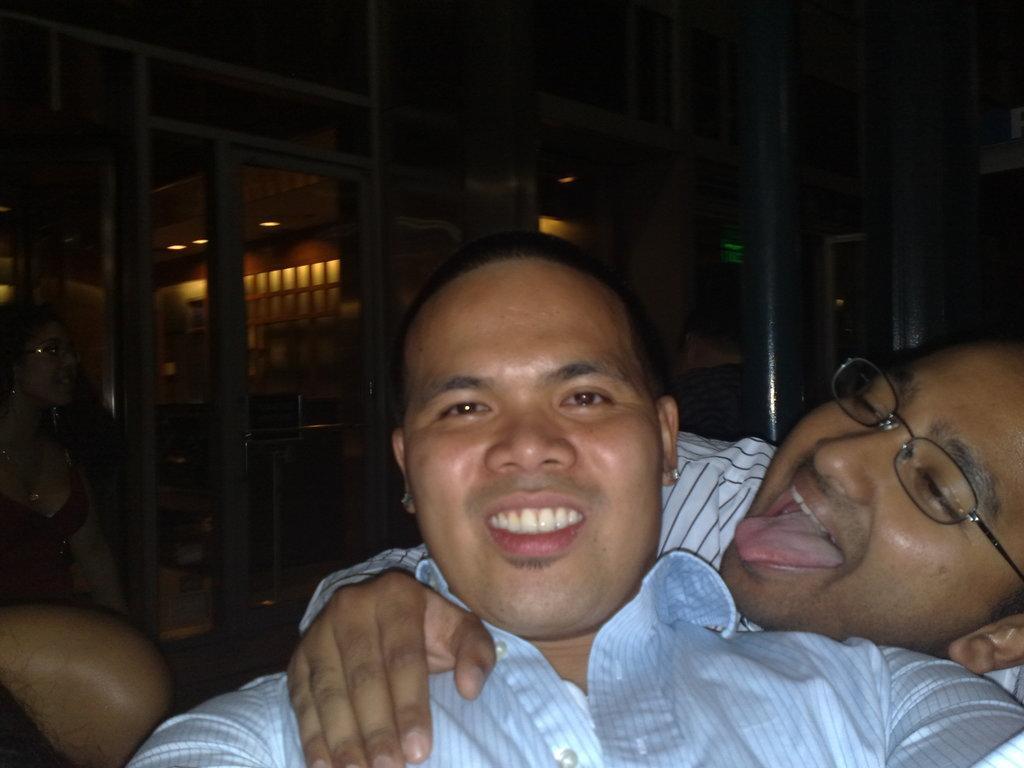How would you summarize this image in a sentence or two? In this image there are people. In the background there is a wall and lights. 